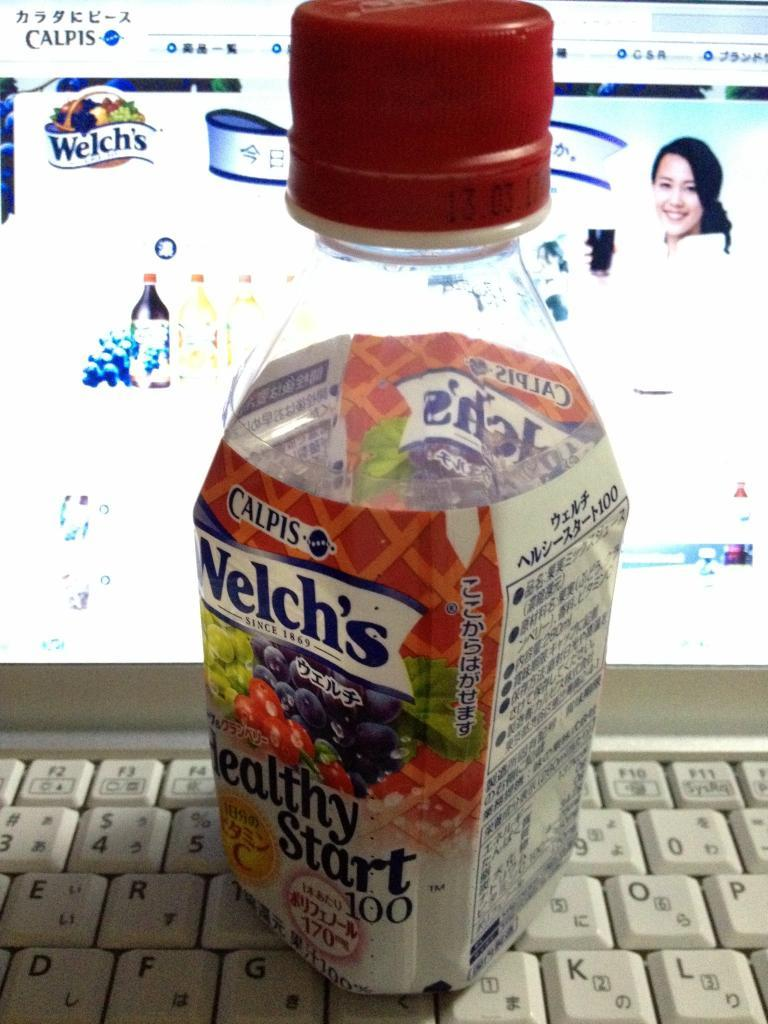<image>
Write a terse but informative summary of the picture. A bottle of Welch's Healthy Start sits on a laptop keyboard. 